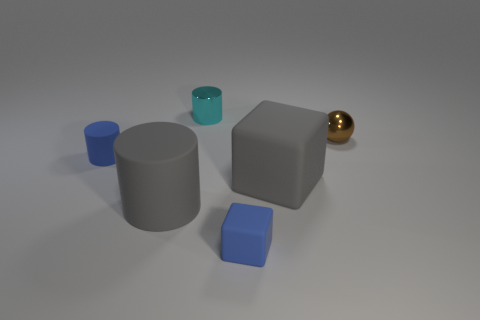Add 4 small cyan objects. How many objects exist? 10 Subtract all cubes. How many objects are left? 4 Subtract all small matte objects. Subtract all big cubes. How many objects are left? 3 Add 3 gray things. How many gray things are left? 5 Add 4 tiny balls. How many tiny balls exist? 5 Subtract 0 blue balls. How many objects are left? 6 